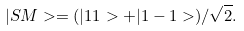<formula> <loc_0><loc_0><loc_500><loc_500>| S M > = ( | 1 1 > + | 1 - 1 > ) / \sqrt { 2 } .</formula> 